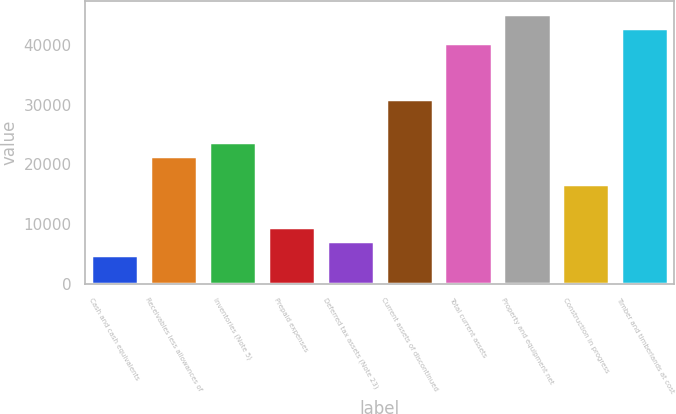Convert chart. <chart><loc_0><loc_0><loc_500><loc_500><bar_chart><fcel>Cash and cash equivalents<fcel>Receivables less allowances of<fcel>Inventories (Note 5)<fcel>Prepaid expenses<fcel>Deferred tax assets (Note 23)<fcel>Current assets of discontinued<fcel>Total current assets<fcel>Property and equipment net<fcel>Construction in progress<fcel>Timber and timberlands at cost<nl><fcel>4807.6<fcel>21431.2<fcel>23806<fcel>9557.2<fcel>7182.4<fcel>30930.4<fcel>40429.6<fcel>45179.2<fcel>16681.6<fcel>42804.4<nl></chart> 